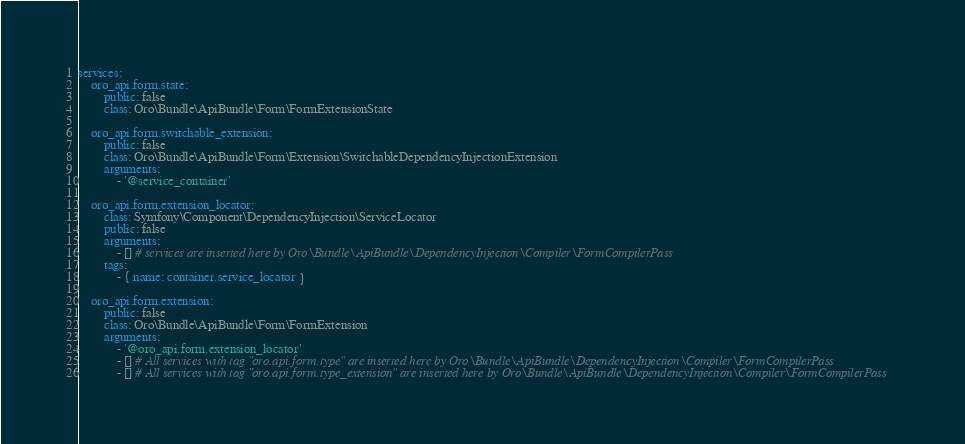Convert code to text. <code><loc_0><loc_0><loc_500><loc_500><_YAML_>services:
    oro_api.form.state:
        public: false
        class: Oro\Bundle\ApiBundle\Form\FormExtensionState

    oro_api.form.switchable_extension:
        public: false
        class: Oro\Bundle\ApiBundle\Form\Extension\SwitchableDependencyInjectionExtension
        arguments:
            - '@service_container'

    oro_api.form.extension_locator:
        class: Symfony\Component\DependencyInjection\ServiceLocator
        public: false
        arguments:
            - [] # services are inserted here by Oro\Bundle\ApiBundle\DependencyInjection\Compiler\FormCompilerPass
        tags:
            - { name: container.service_locator }

    oro_api.form.extension:
        public: false
        class: Oro\Bundle\ApiBundle\Form\FormExtension
        arguments:
            - '@oro_api.form.extension_locator'
            - [] # All services with tag "oro.api.form.type" are inserted here by Oro\Bundle\ApiBundle\DependencyInjection\Compiler\FormCompilerPass
            - [] # All services with tag "oro.api.form.type_extension" are inserted here by Oro\Bundle\ApiBundle\DependencyInjection\Compiler\FormCompilerPass</code> 